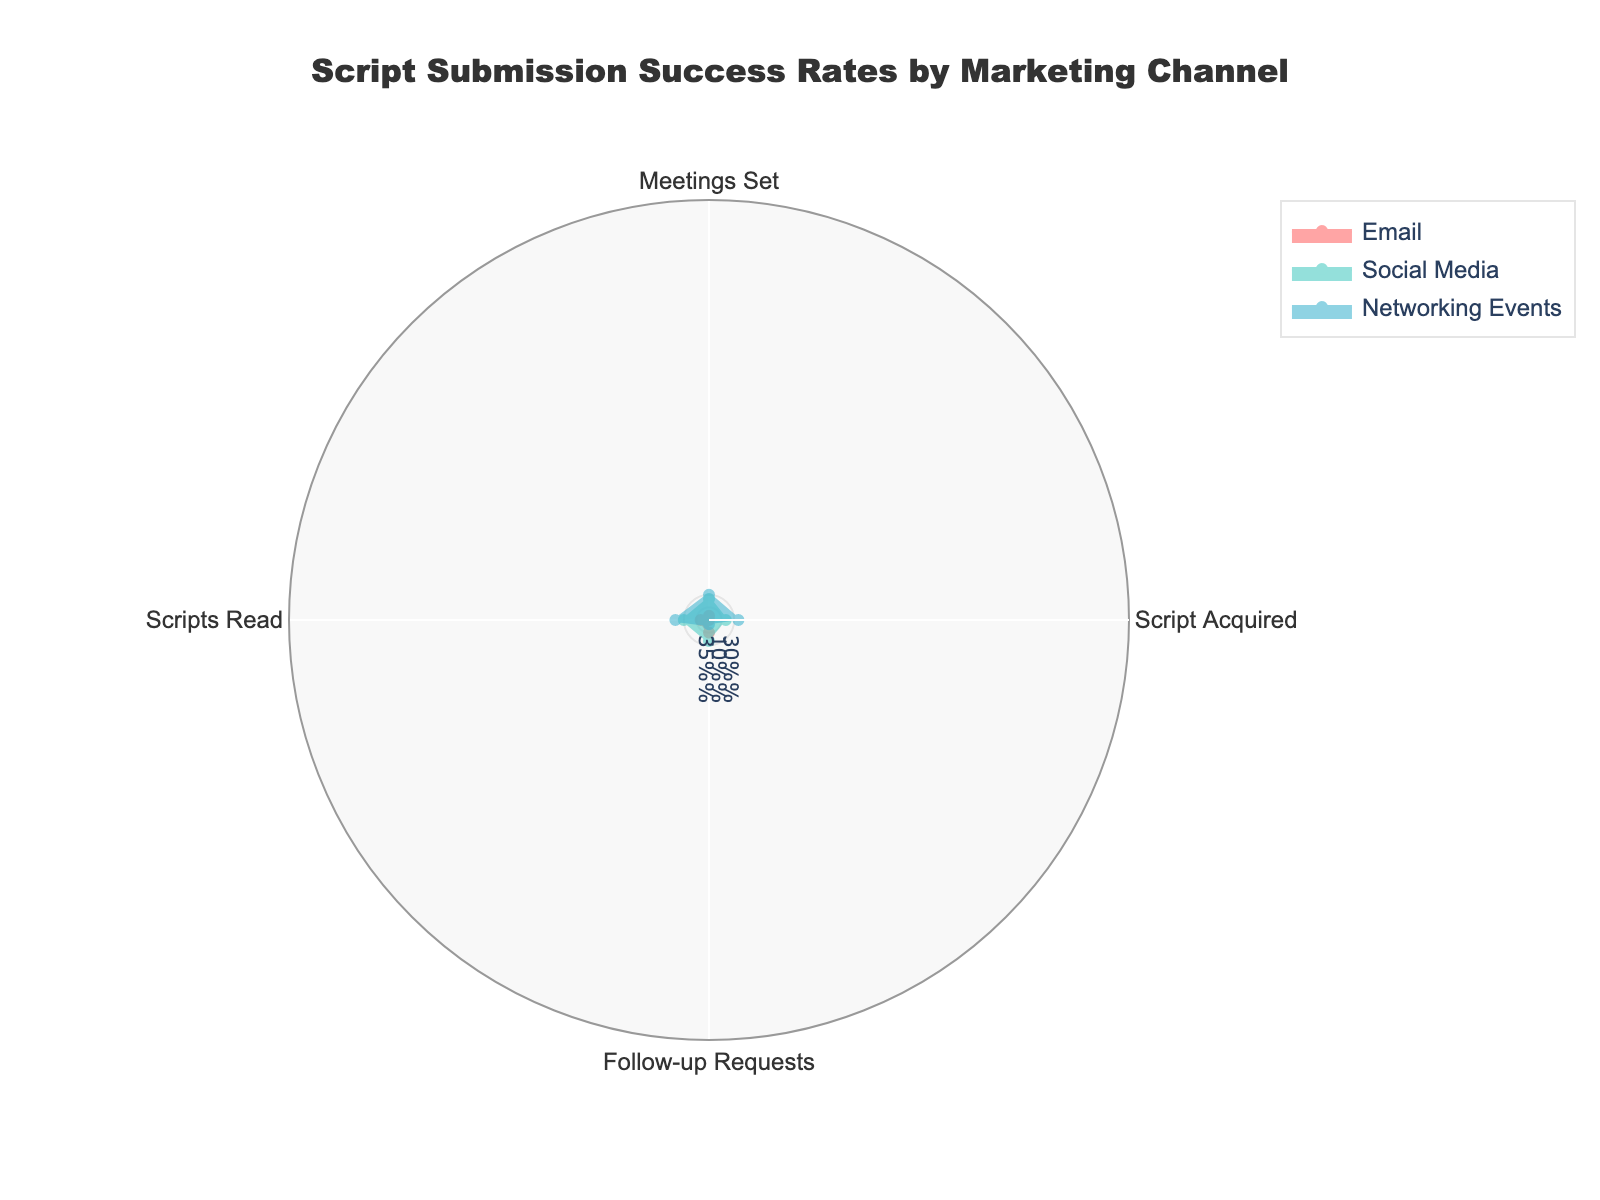What is the title of the radar chart? The title of the radar chart is typically displayed at the top of the figure. By looking at the top of the figure, we can read the title directly.
Answer: Script Submission Success Rates by Marketing Channel How many categories (axes) are displayed on the radar chart? The radar chart typically displays various axes for different categories. By counting the axes, we can determine the number of categories.
Answer: 4 Which marketing channel has the highest value for "Follow-up Requests"? To determine which channel has the highest value for "Follow-up Requests", identify the corresponding values for each channel and compare them.
Answer: Networking Events What is the difference in the "Script Acquired" rate between Networking Events and Social Media? First, identify the "Script Acquired" rates for Networking Events and Social Media. Then, subtract the rate of Social Media from the rate of Networking Events.
Answer: 30% Which marketing channel shows the lowest value in the "Meetings Set" category? To find the lowest value in the "Meetings Set" category, look at the values corresponding to each channel and identify the smallest one.
Answer: Social Media What are the values for "Scripts Read" in all marketing channels? Identify the "Scripts Read" values for each marketing channel displayed on the radar chart.
Answer: Email: 50%, Social Media: 30%, Networking Events: 55% Which channel has a higher percentage for "Script Acquired", Email or Networking Events? Compare the "Script Acquired" percentages for both Email and Networking Events.
Answer: Networking Events Across all categories, which channel has the most consistent (least varying) performance? To find the most consistent channel, consider the values across all categories for each channel and determine which one has the least variation from the mean.
Answer: Networking Events Is there any category where Social Media outperforms Email? Compare the values for each category between Social Media and Email to identify if Social Media has a higher value in any category.
Answer: No 